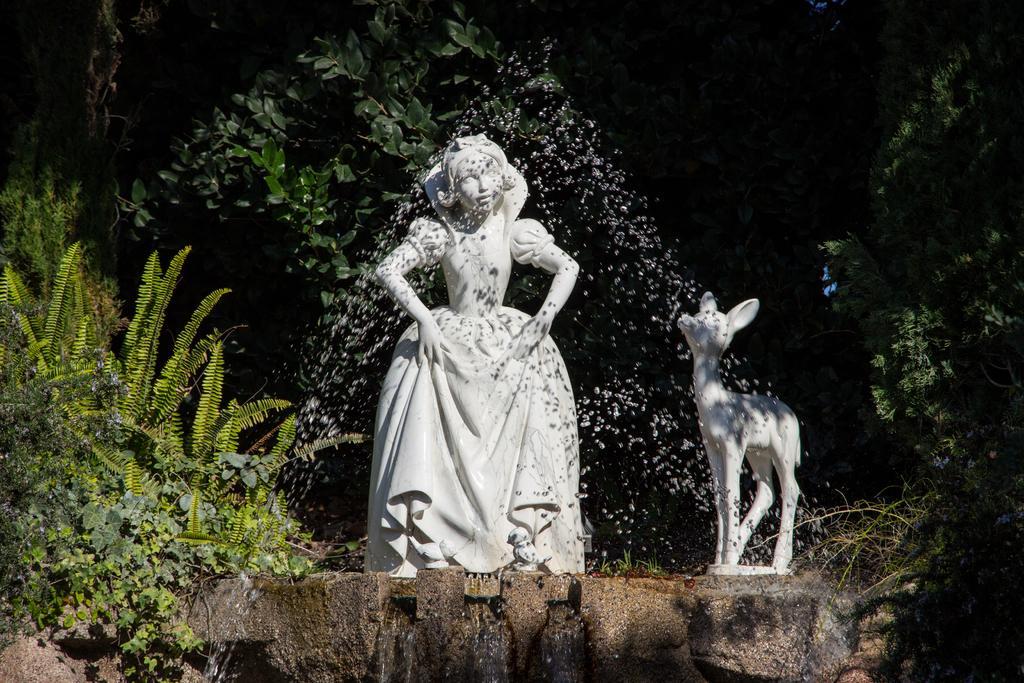Can you describe this image briefly? In this image I can see the statues of the person and an animal. These are is ash color. In the background I can see many trees. I can also see the fountain in-front of these statues. 